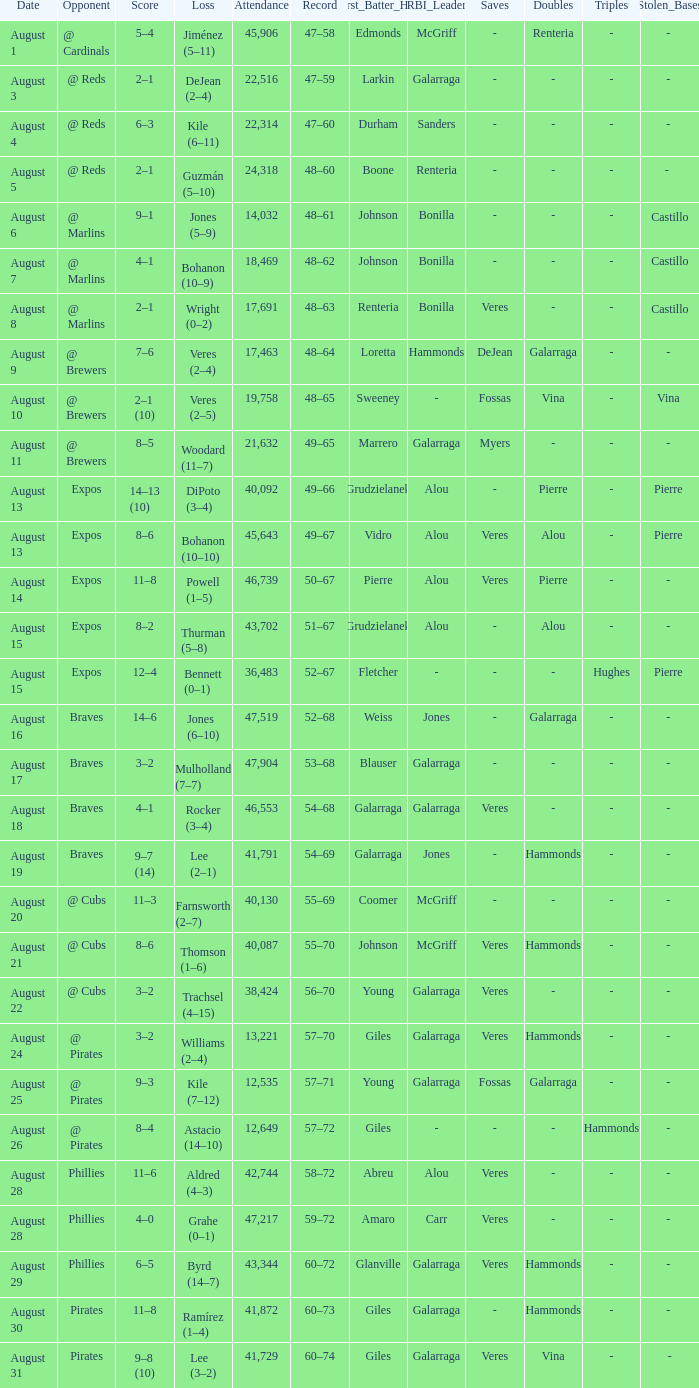What is the lowest attendance total on August 26? 12649.0. 